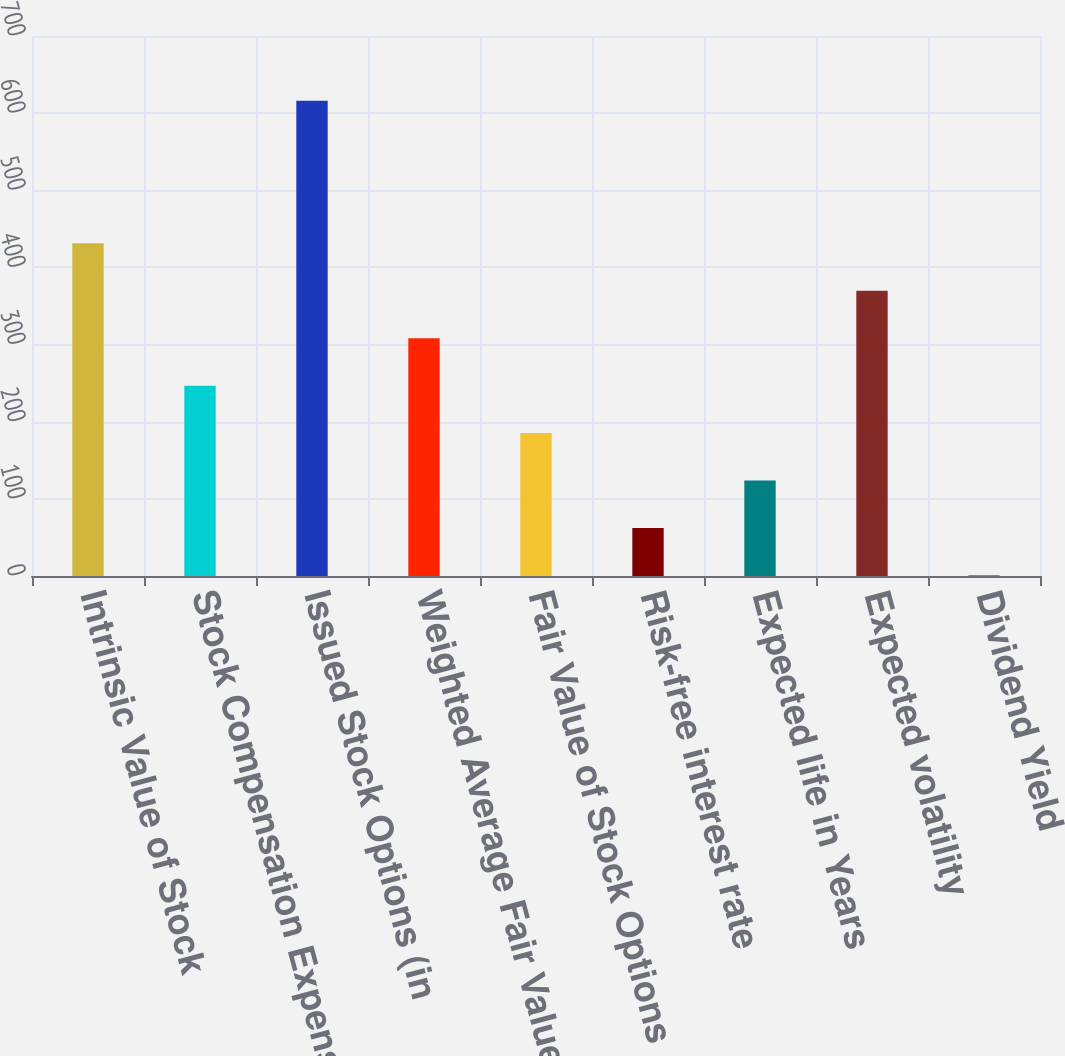<chart> <loc_0><loc_0><loc_500><loc_500><bar_chart><fcel>Intrinsic Value of Stock<fcel>Stock Compensation Expense<fcel>Issued Stock Options (in<fcel>Weighted Average Fair Value of<fcel>Fair Value of Stock Options<fcel>Risk-free interest rate<fcel>Expected life in Years<fcel>Expected volatility<fcel>Dividend Yield<nl><fcel>431.38<fcel>246.76<fcel>616<fcel>308.3<fcel>185.22<fcel>62.14<fcel>123.68<fcel>369.84<fcel>0.6<nl></chart> 